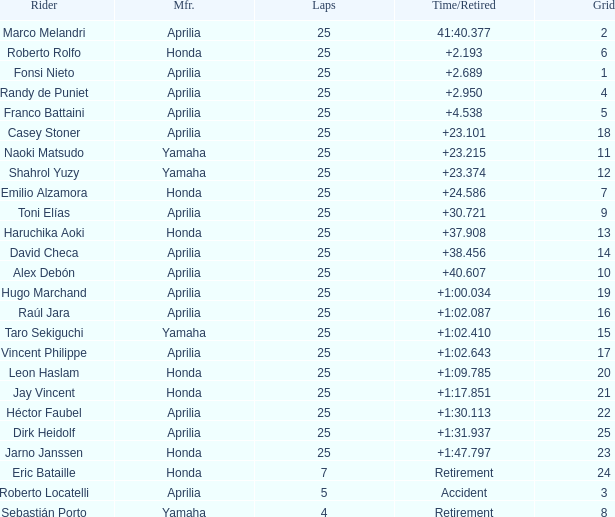Which Manufacturer has a Time/Retired of accident? Aprilia. 